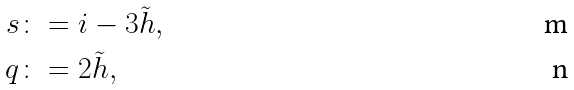Convert formula to latex. <formula><loc_0><loc_0><loc_500><loc_500>s & \colon = i - 3 \tilde { h } , \\ q & \colon = 2 \tilde { h } ,</formula> 